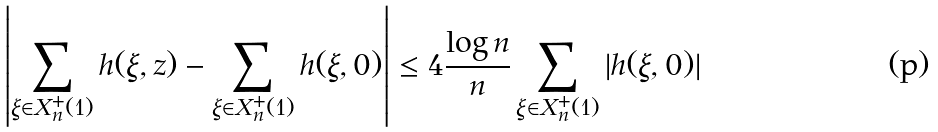<formula> <loc_0><loc_0><loc_500><loc_500>\left | \sum _ { \xi \in X _ { n } ^ { + } ( 1 ) } h ( \xi , z ) - \sum _ { \xi \in X _ { n } ^ { + } ( 1 ) } h ( \xi , 0 ) \right | \leq 4 \frac { \log n } { n } \sum _ { \xi \in X _ { n } ^ { + } ( 1 ) } | h ( \xi , 0 ) |</formula> 